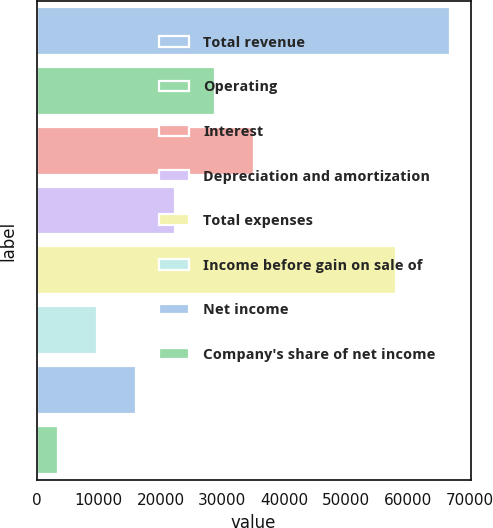Convert chart. <chart><loc_0><loc_0><loc_500><loc_500><bar_chart><fcel>Total revenue<fcel>Operating<fcel>Interest<fcel>Depreciation and amortization<fcel>Total expenses<fcel>Income before gain on sale of<fcel>Net income<fcel>Company's share of net income<nl><fcel>66755<fcel>28730<fcel>35067.5<fcel>22392.5<fcel>57990<fcel>9717.5<fcel>16055<fcel>3380<nl></chart> 